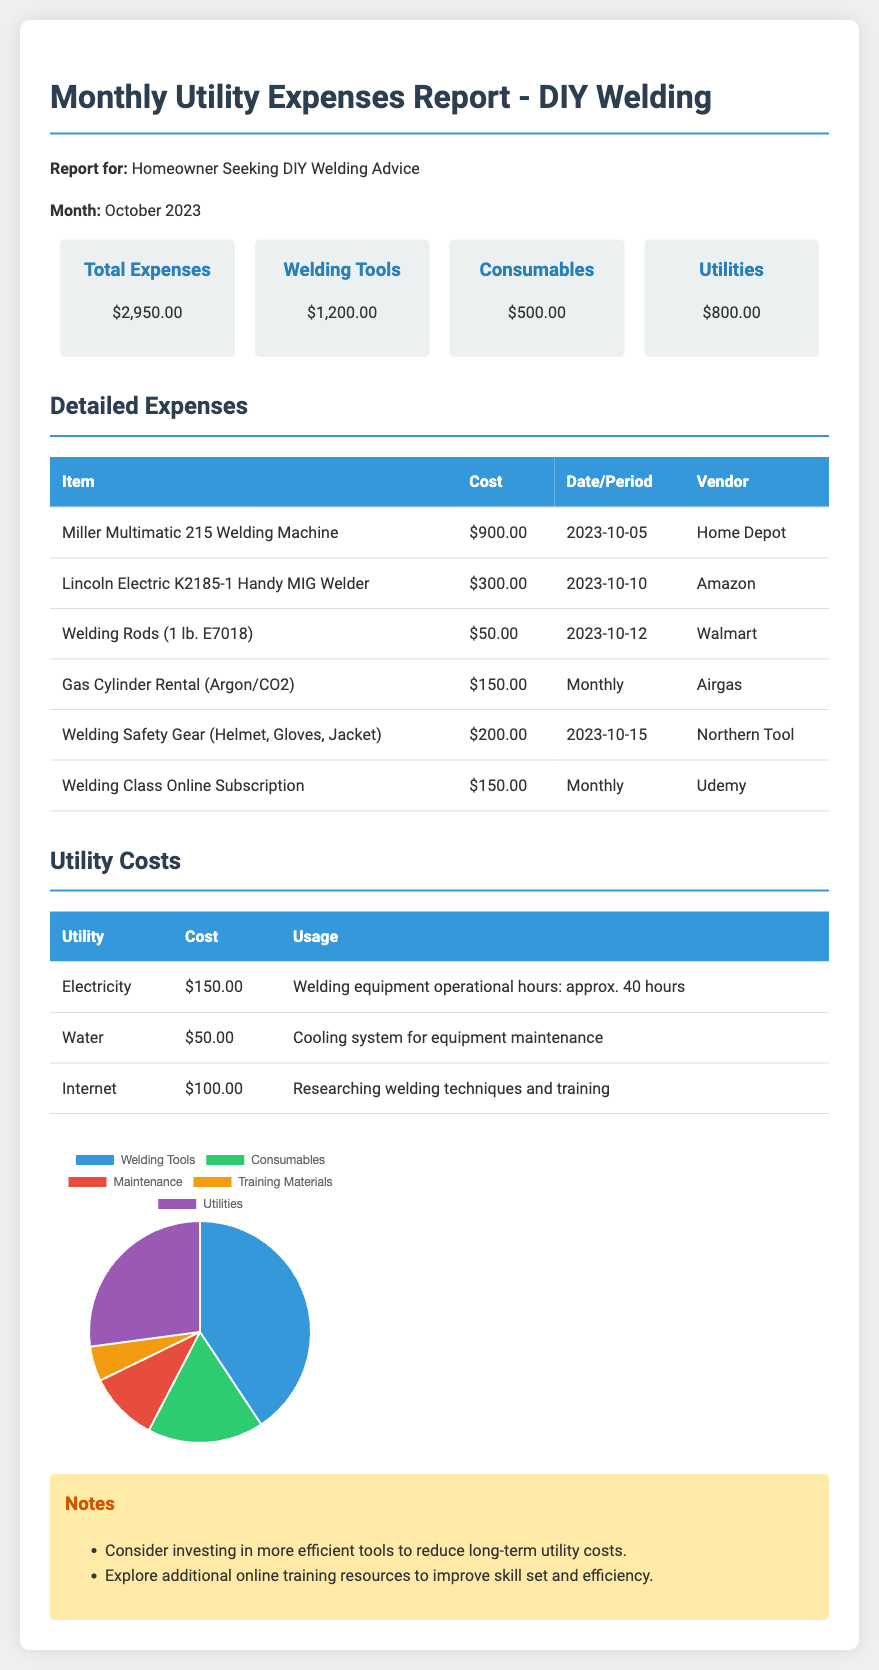what is the total expenses? The total expenses of the month are stated in the summary section.
Answer: $2,950.00 how much was spent on welding tools? The amount spent on welding tools is provided in the summary.
Answer: $1,200.00 what is the cost of the Miller Multimatic 215 Welding Machine? The cost of the item is noted in the detailed expenses table.
Answer: $900.00 when was the Lincoln Electric K2185-1 Handy MIG Welder purchased? The purchase date for this welder is listed in the detailed expenses section.
Answer: 2023-10-10 how much is the monthly cost for Gas Cylinder Rental? The monthly cost of this utility is stated in the detailed expenses section.
Answer: $150.00 how much did the homeowner spend on consumables? The amount spent on consumables is summed in the summary section of the report.
Answer: $500.00 what was the cost of electricity for the month? The electricity cost is specified in the utility costs table.
Answer: $150.00 which vendor supplied the Welding Safety Gear? The vendor for the welding safety gear is mentioned in the detailed expenses table.
Answer: Northern Tool how much was budgeted for training materials? The cost for training materials can be inferred from the training entry in detailed expenses.
Answer: $150.00 